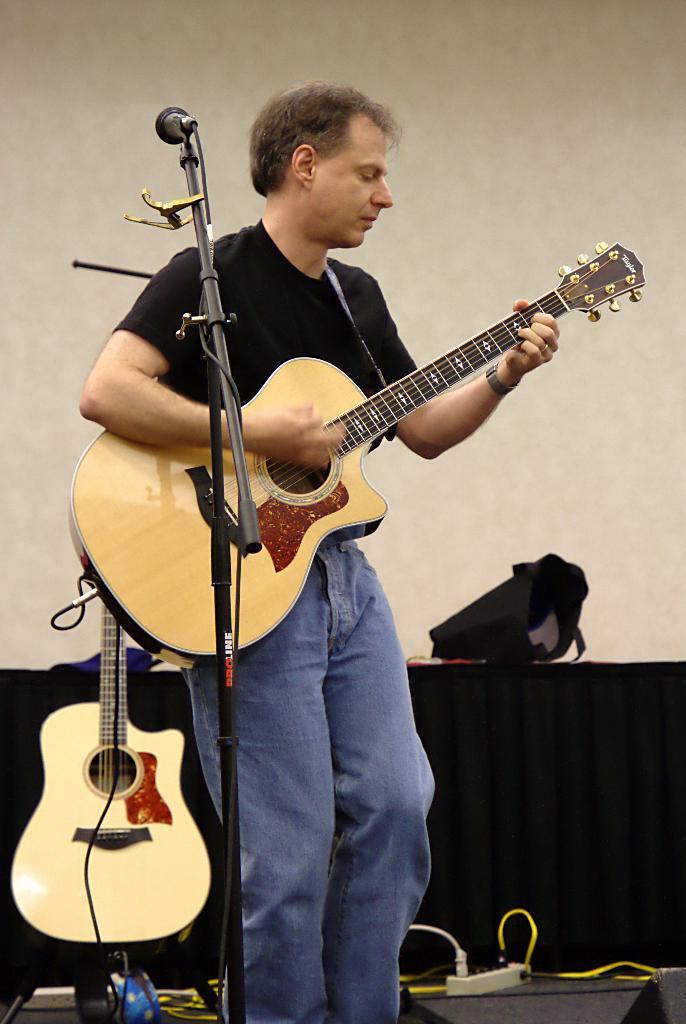Can you describe this image briefly? there is a person standing in front of a microphone and playing guitar 